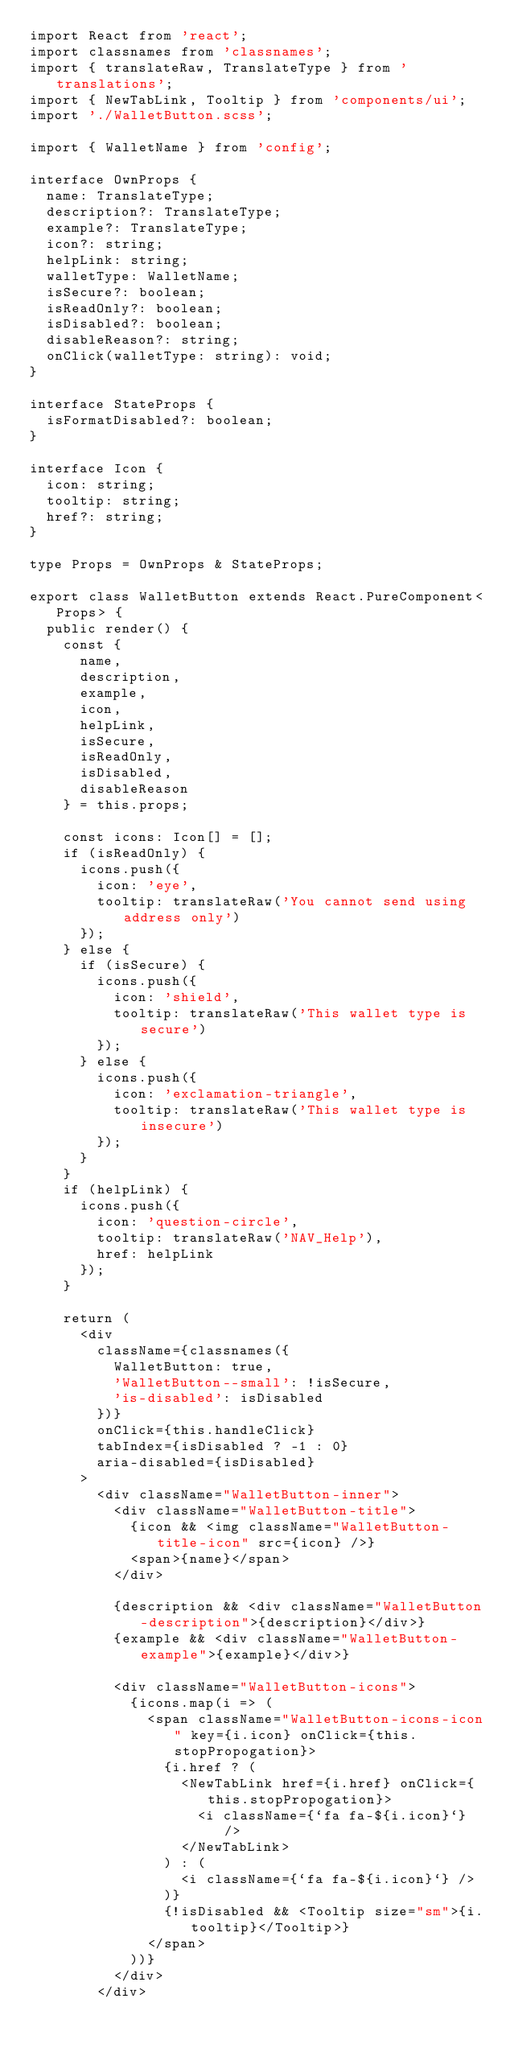Convert code to text. <code><loc_0><loc_0><loc_500><loc_500><_TypeScript_>import React from 'react';
import classnames from 'classnames';
import { translateRaw, TranslateType } from 'translations';
import { NewTabLink, Tooltip } from 'components/ui';
import './WalletButton.scss';

import { WalletName } from 'config';

interface OwnProps {
  name: TranslateType;
  description?: TranslateType;
  example?: TranslateType;
  icon?: string;
  helpLink: string;
  walletType: WalletName;
  isSecure?: boolean;
  isReadOnly?: boolean;
  isDisabled?: boolean;
  disableReason?: string;
  onClick(walletType: string): void;
}

interface StateProps {
  isFormatDisabled?: boolean;
}

interface Icon {
  icon: string;
  tooltip: string;
  href?: string;
}

type Props = OwnProps & StateProps;

export class WalletButton extends React.PureComponent<Props> {
  public render() {
    const {
      name,
      description,
      example,
      icon,
      helpLink,
      isSecure,
      isReadOnly,
      isDisabled,
      disableReason
    } = this.props;

    const icons: Icon[] = [];
    if (isReadOnly) {
      icons.push({
        icon: 'eye',
        tooltip: translateRaw('You cannot send using address only')
      });
    } else {
      if (isSecure) {
        icons.push({
          icon: 'shield',
          tooltip: translateRaw('This wallet type is secure')
        });
      } else {
        icons.push({
          icon: 'exclamation-triangle',
          tooltip: translateRaw('This wallet type is insecure')
        });
      }
    }
    if (helpLink) {
      icons.push({
        icon: 'question-circle',
        tooltip: translateRaw('NAV_Help'),
        href: helpLink
      });
    }

    return (
      <div
        className={classnames({
          WalletButton: true,
          'WalletButton--small': !isSecure,
          'is-disabled': isDisabled
        })}
        onClick={this.handleClick}
        tabIndex={isDisabled ? -1 : 0}
        aria-disabled={isDisabled}
      >
        <div className="WalletButton-inner">
          <div className="WalletButton-title">
            {icon && <img className="WalletButton-title-icon" src={icon} />}
            <span>{name}</span>
          </div>

          {description && <div className="WalletButton-description">{description}</div>}
          {example && <div className="WalletButton-example">{example}</div>}

          <div className="WalletButton-icons">
            {icons.map(i => (
              <span className="WalletButton-icons-icon" key={i.icon} onClick={this.stopPropogation}>
                {i.href ? (
                  <NewTabLink href={i.href} onClick={this.stopPropogation}>
                    <i className={`fa fa-${i.icon}`} />
                  </NewTabLink>
                ) : (
                  <i className={`fa fa-${i.icon}`} />
                )}
                {!isDisabled && <Tooltip size="sm">{i.tooltip}</Tooltip>}
              </span>
            ))}
          </div>
        </div>
</code> 